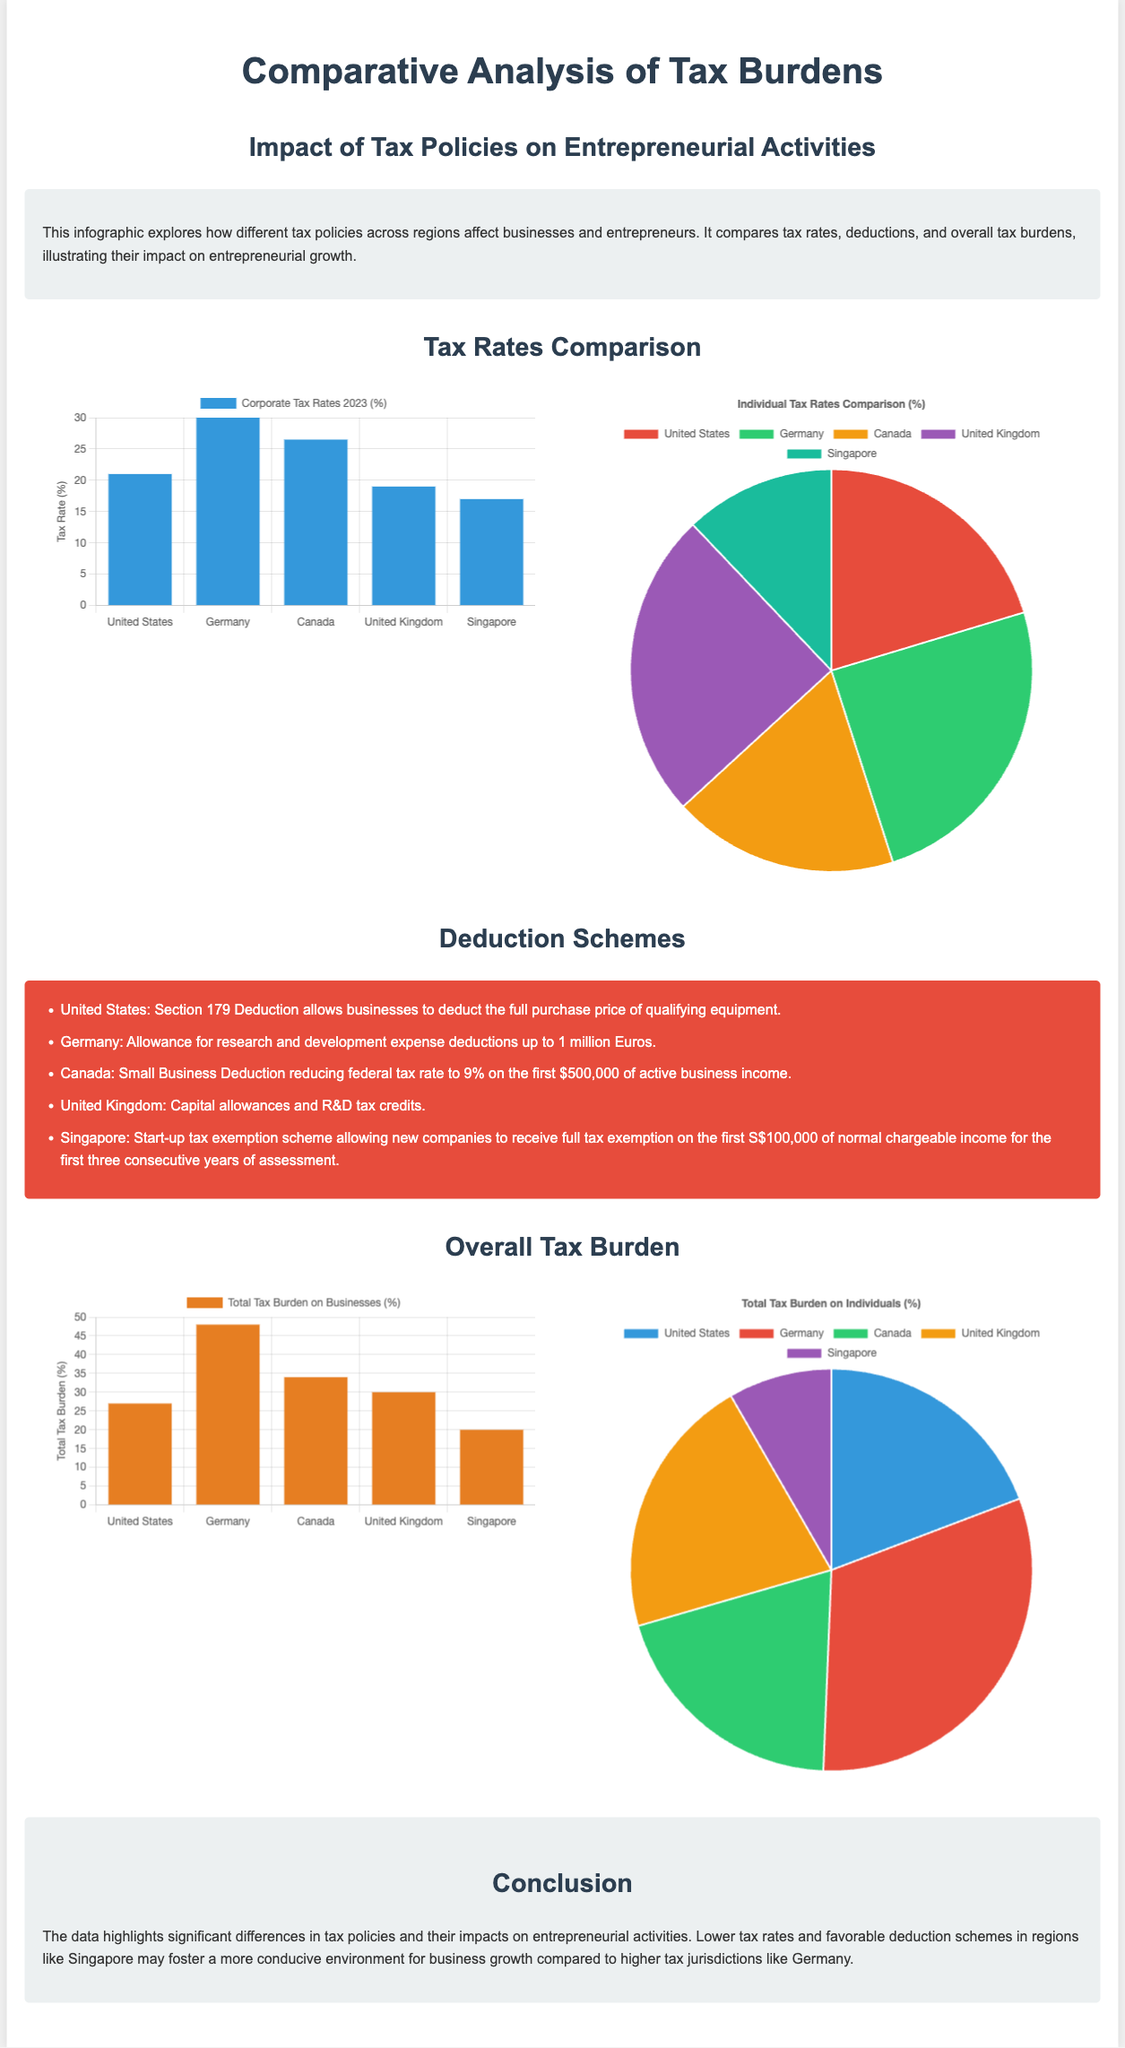What is the corporate tax rate in Germany? The corporate tax rate in Germany is listed as 30% in the document.
Answer: 30% Which region offers the lowest individual tax rate? The pie chart shows that Singapore has the lowest individual tax rate at 22%.
Answer: 22% What deduction scheme is available in Canada? The document mentions the Small Business Deduction which reduces the federal tax rate to 9% on the first $500,000.
Answer: Small Business Deduction Which region has the highest total tax burden on businesses? The bar chart indicates that Germany has the highest total tax burden on businesses at 48%.
Answer: 48% What is the overall total tax burden on individuals in Singapore? The pie chart indicates that the total tax burden on individuals in Singapore is 13%.
Answer: 13% Which country allows full tax exemption on the first chargeable income for new companies? The document states that Singapore allows full tax exemption on the first S$100,000 of normal chargeable income.
Answer: Singapore What is the primary focus of this infographic? The introduction highlights that the focus is on how different tax policies affect businesses and entrepreneurs.
Answer: Tax policies impact on businesses Which tax rate is higher, Canada’s corporate tax rate or the United Kingdom's? The bar chart shows Canada's corporate tax rate as 26.5%, and the United Kingdom's as 19%, indicating Canada is higher.
Answer: Canada What conclusion is drawn about tax rates and entrepreneurial growth? The conclusion notes that lower tax rates in regions like Singapore foster a more conducive environment for business growth.
Answer: Lower tax rates in Singapore foster growth 